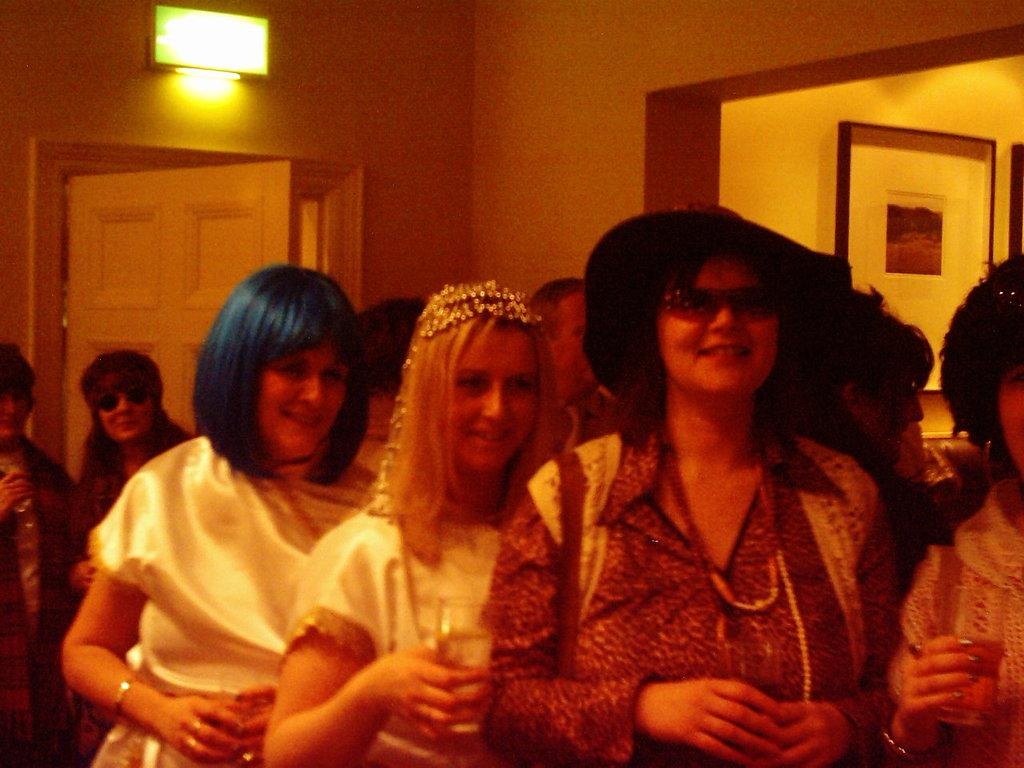What can be seen in the image related to people? There are persons wearing clothes in the image. Where is the door located in the image? The door is on the left side of the image. What can be seen in the top left corner of the image? There is a light in the top left of the image. What type of bucket is being used by the minister in the image? There is no minister or bucket present in the image. 